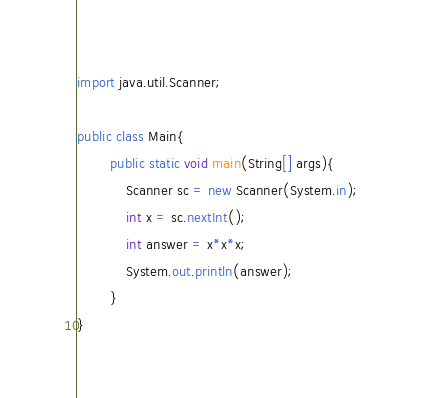<code> <loc_0><loc_0><loc_500><loc_500><_Java_>import java.util.Scanner;

public class Main{
		public static void main(String[] args){
			Scanner sc = new Scanner(System.in);
			int x = sc.nextInt();
			int answer = x*x*x;
			System.out.println(answer);
		}
}</code> 